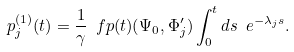Convert formula to latex. <formula><loc_0><loc_0><loc_500><loc_500>p ^ { ( 1 ) } _ { j } ( t ) = \frac { 1 } { \gamma } \ f p ( t ) ( \Psi _ { 0 } , \Phi ^ { \prime } _ { j } ) \int _ { 0 } ^ { t } d s \ e ^ { - \lambda _ { j } s } .</formula> 